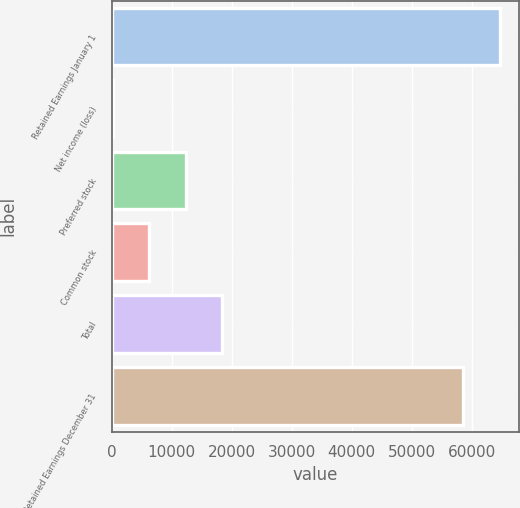Convert chart. <chart><loc_0><loc_0><loc_500><loc_500><bar_chart><fcel>Retained Earnings January 1<fcel>Net income (loss)<fcel>Preferred stock<fcel>Common stock<fcel>Total<fcel>Retained Earnings December 31<nl><fcel>64662.9<fcel>230<fcel>12307.8<fcel>6268.9<fcel>18346.7<fcel>58624<nl></chart> 